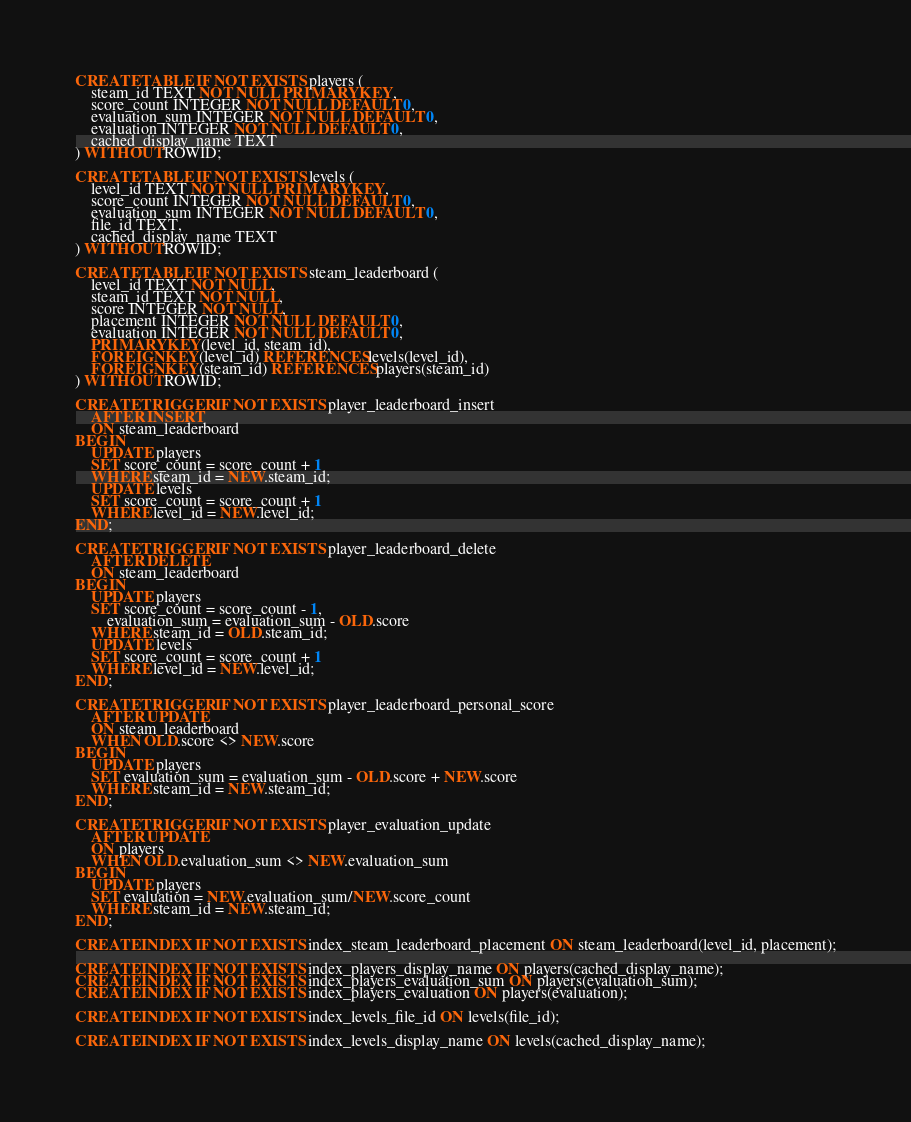<code> <loc_0><loc_0><loc_500><loc_500><_SQL_>CREATE TABLE IF NOT EXISTS players (
	steam_id TEXT NOT NULL PRIMARY KEY,
	score_count INTEGER NOT NULL DEFAULT 0,
	evaluation_sum INTEGER NOT NULL DEFAULT 0,
	evaluation INTEGER NOT NULL DEFAULT 0,
	cached_display_name TEXT
) WITHOUT ROWID;

CREATE TABLE IF NOT EXISTS levels (
	level_id TEXT NOT NULL PRIMARY KEY,
	score_count INTEGER NOT NULL DEFAULT 0,
	evaluation_sum INTEGER NOT NULL DEFAULT 0,
	file_id TEXT,
	cached_display_name TEXT
) WITHOUT ROWID;

CREATE TABLE IF NOT EXISTS steam_leaderboard (
	level_id TEXT NOT NULL,
	steam_id TEXT NOT NULL,
	score INTEGER NOT NULL,
	placement INTEGER NOT NULL DEFAULT 0,
	evaluation INTEGER NOT NULL DEFAULT 0,
	PRIMARY KEY(level_id, steam_id),
	FOREIGN KEY(level_id) REFERENCES levels(level_id),
	FOREIGN KEY(steam_id) REFERENCES players(steam_id)
) WITHOUT ROWID;

CREATE TRIGGER IF NOT EXISTS player_leaderboard_insert
	AFTER INSERT
	ON steam_leaderboard
BEGIN
	UPDATE players
	SET score_count = score_count + 1
	WHERE steam_id = NEW.steam_id;
	UPDATE levels
	SET score_count = score_count + 1
	WHERE level_id = NEW.level_id;
END;

CREATE TRIGGER IF NOT EXISTS player_leaderboard_delete
	AFTER DELETE
	ON steam_leaderboard
BEGIN
	UPDATE players
	SET score_count = score_count - 1,
		evaluation_sum = evaluation_sum - OLD.score
	WHERE steam_id = OLD.steam_id;
	UPDATE levels
	SET score_count = score_count + 1
	WHERE level_id = NEW.level_id;
END;

CREATE TRIGGER IF NOT EXISTS player_leaderboard_personal_score
	AFTER UPDATE
	ON steam_leaderboard
	WHEN OLD.score <> NEW.score
BEGIN
	UPDATE players
	SET evaluation_sum = evaluation_sum - OLD.score + NEW.score
	WHERE steam_id = NEW.steam_id;
END;

CREATE TRIGGER IF NOT EXISTS player_evaluation_update
	AFTER UPDATE
	ON players
	WHEN OLD.evaluation_sum <> NEW.evaluation_sum
BEGIN
	UPDATE players
	SET evaluation = NEW.evaluation_sum/NEW.score_count
	WHERE steam_id = NEW.steam_id;
END;

CREATE INDEX IF NOT EXISTS index_steam_leaderboard_placement ON steam_leaderboard(level_id, placement);

CREATE INDEX IF NOT EXISTS index_players_display_name ON players(cached_display_name);
CREATE INDEX IF NOT EXISTS index_players_evaluation_sum ON players(evaluation_sum);
CREATE INDEX IF NOT EXISTS index_players_evaluation ON players(evaluation);

CREATE INDEX IF NOT EXISTS index_levels_file_id ON levels(file_id);

CREATE INDEX IF NOT EXISTS index_levels_display_name ON levels(cached_display_name);</code> 